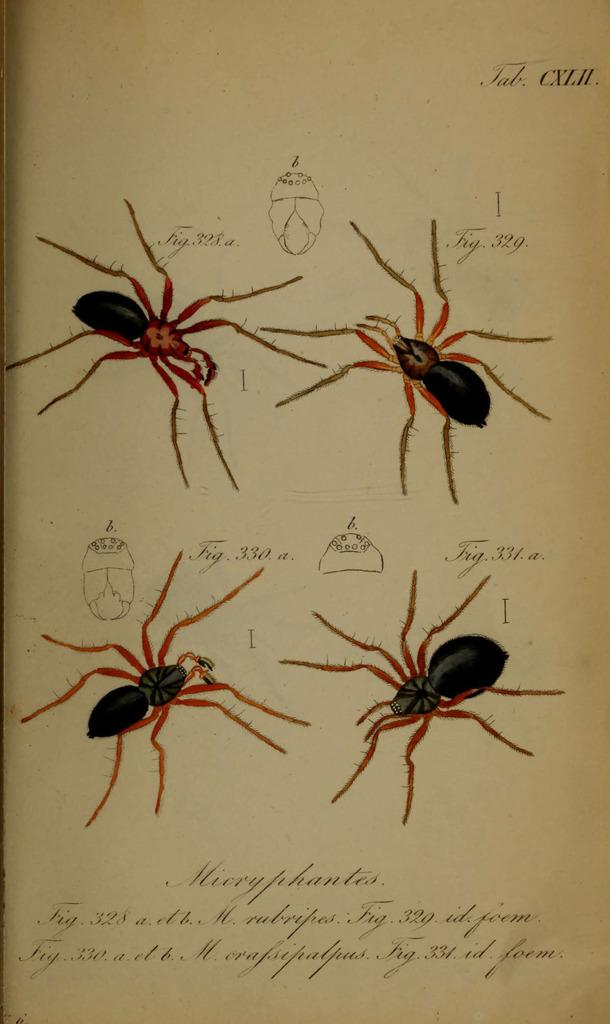What is depicted in the sketch in the image? There is a sketch of spiders in the image. What else can be seen on the paper in the image? There is something written on the paper in the image. What type of behavior does the scarecrow exhibit in the image? There is no scarecrow present in the image, so it is not possible to determine its behavior. 